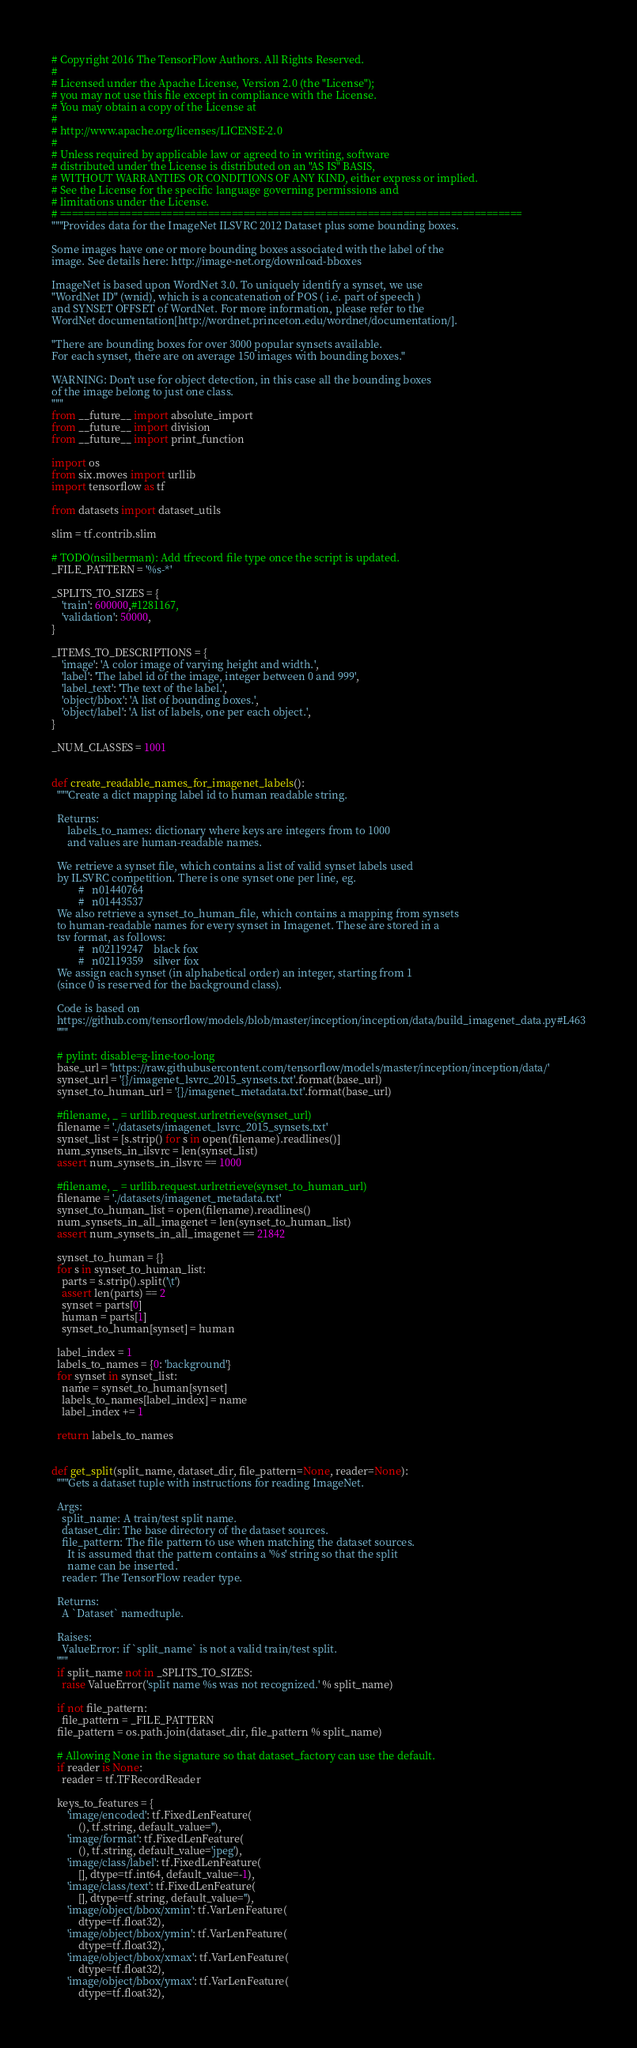<code> <loc_0><loc_0><loc_500><loc_500><_Python_># Copyright 2016 The TensorFlow Authors. All Rights Reserved.
#
# Licensed under the Apache License, Version 2.0 (the "License");
# you may not use this file except in compliance with the License.
# You may obtain a copy of the License at
#
# http://www.apache.org/licenses/LICENSE-2.0
#
# Unless required by applicable law or agreed to in writing, software
# distributed under the License is distributed on an "AS IS" BASIS,
# WITHOUT WARRANTIES OR CONDITIONS OF ANY KIND, either express or implied.
# See the License for the specific language governing permissions and
# limitations under the License.
# ==============================================================================
"""Provides data for the ImageNet ILSVRC 2012 Dataset plus some bounding boxes.

Some images have one or more bounding boxes associated with the label of the
image. See details here: http://image-net.org/download-bboxes

ImageNet is based upon WordNet 3.0. To uniquely identify a synset, we use
"WordNet ID" (wnid), which is a concatenation of POS ( i.e. part of speech )
and SYNSET OFFSET of WordNet. For more information, please refer to the
WordNet documentation[http://wordnet.princeton.edu/wordnet/documentation/].

"There are bounding boxes for over 3000 popular synsets available.
For each synset, there are on average 150 images with bounding boxes."

WARNING: Don't use for object detection, in this case all the bounding boxes
of the image belong to just one class.
"""
from __future__ import absolute_import
from __future__ import division
from __future__ import print_function

import os
from six.moves import urllib
import tensorflow as tf

from datasets import dataset_utils

slim = tf.contrib.slim

# TODO(nsilberman): Add tfrecord file type once the script is updated.
_FILE_PATTERN = '%s-*'

_SPLITS_TO_SIZES = {
    'train': 600000,#1281167,
    'validation': 50000,
}

_ITEMS_TO_DESCRIPTIONS = {
    'image': 'A color image of varying height and width.',
    'label': 'The label id of the image, integer between 0 and 999',
    'label_text': 'The text of the label.',
    'object/bbox': 'A list of bounding boxes.',
    'object/label': 'A list of labels, one per each object.',
}

_NUM_CLASSES = 1001


def create_readable_names_for_imagenet_labels():
  """Create a dict mapping label id to human readable string.

  Returns:
      labels_to_names: dictionary where keys are integers from to 1000
      and values are human-readable names.

  We retrieve a synset file, which contains a list of valid synset labels used
  by ILSVRC competition. There is one synset one per line, eg.
          #   n01440764
          #   n01443537
  We also retrieve a synset_to_human_file, which contains a mapping from synsets
  to human-readable names for every synset in Imagenet. These are stored in a
  tsv format, as follows:
          #   n02119247    black fox
          #   n02119359    silver fox
  We assign each synset (in alphabetical order) an integer, starting from 1
  (since 0 is reserved for the background class).

  Code is based on
  https://github.com/tensorflow/models/blob/master/inception/inception/data/build_imagenet_data.py#L463
  """

  # pylint: disable=g-line-too-long
  base_url = 'https://raw.githubusercontent.com/tensorflow/models/master/inception/inception/data/'
  synset_url = '{}/imagenet_lsvrc_2015_synsets.txt'.format(base_url)
  synset_to_human_url = '{}/imagenet_metadata.txt'.format(base_url)

  #filename, _ = urllib.request.urlretrieve(synset_url)
  filename = './datasets/imagenet_lsvrc_2015_synsets.txt'
  synset_list = [s.strip() for s in open(filename).readlines()]
  num_synsets_in_ilsvrc = len(synset_list)
  assert num_synsets_in_ilsvrc == 1000

  #filename, _ = urllib.request.urlretrieve(synset_to_human_url)
  filename = './datasets/imagenet_metadata.txt'
  synset_to_human_list = open(filename).readlines()
  num_synsets_in_all_imagenet = len(synset_to_human_list)
  assert num_synsets_in_all_imagenet == 21842

  synset_to_human = {}
  for s in synset_to_human_list:
    parts = s.strip().split('\t')
    assert len(parts) == 2
    synset = parts[0]
    human = parts[1]
    synset_to_human[synset] = human

  label_index = 1
  labels_to_names = {0: 'background'}
  for synset in synset_list:
    name = synset_to_human[synset]
    labels_to_names[label_index] = name
    label_index += 1

  return labels_to_names


def get_split(split_name, dataset_dir, file_pattern=None, reader=None):
  """Gets a dataset tuple with instructions for reading ImageNet.

  Args:
    split_name: A train/test split name.
    dataset_dir: The base directory of the dataset sources.
    file_pattern: The file pattern to use when matching the dataset sources.
      It is assumed that the pattern contains a '%s' string so that the split
      name can be inserted.
    reader: The TensorFlow reader type.

  Returns:
    A `Dataset` namedtuple.

  Raises:
    ValueError: if `split_name` is not a valid train/test split.
  """
  if split_name not in _SPLITS_TO_SIZES:
    raise ValueError('split name %s was not recognized.' % split_name)

  if not file_pattern:
    file_pattern = _FILE_PATTERN
  file_pattern = os.path.join(dataset_dir, file_pattern % split_name)

  # Allowing None in the signature so that dataset_factory can use the default.
  if reader is None:
    reader = tf.TFRecordReader

  keys_to_features = {
      'image/encoded': tf.FixedLenFeature(
          (), tf.string, default_value=''),
      'image/format': tf.FixedLenFeature(
          (), tf.string, default_value='jpeg'),
      'image/class/label': tf.FixedLenFeature(
          [], dtype=tf.int64, default_value=-1),
      'image/class/text': tf.FixedLenFeature(
          [], dtype=tf.string, default_value=''),
      'image/object/bbox/xmin': tf.VarLenFeature(
          dtype=tf.float32),
      'image/object/bbox/ymin': tf.VarLenFeature(
          dtype=tf.float32),
      'image/object/bbox/xmax': tf.VarLenFeature(
          dtype=tf.float32),
      'image/object/bbox/ymax': tf.VarLenFeature(
          dtype=tf.float32),</code> 